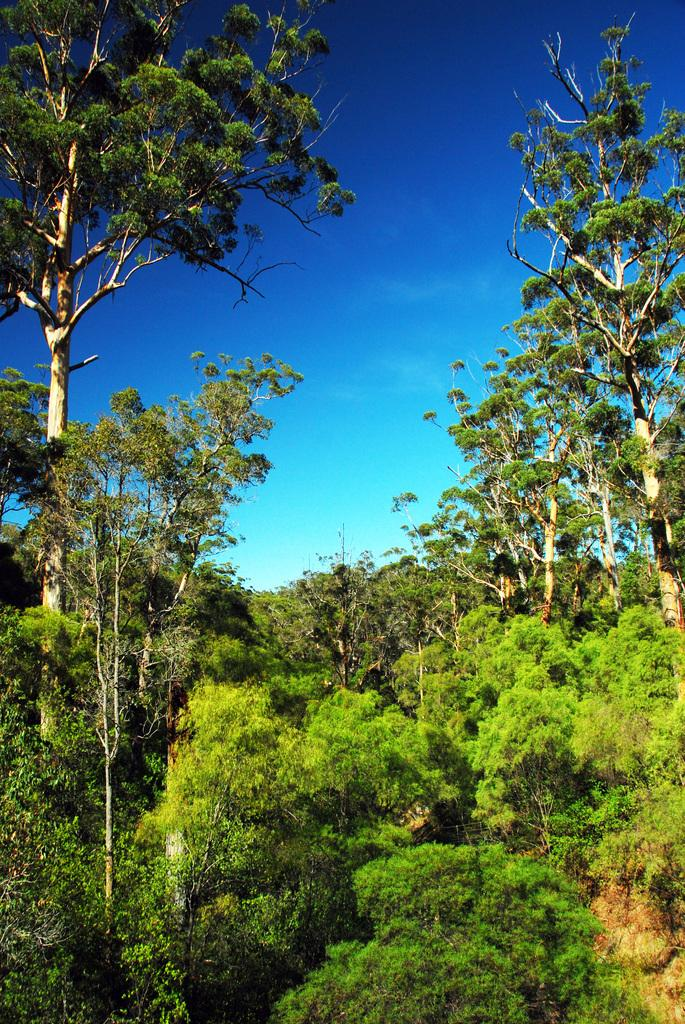What type of natural environment is depicted in the image? There is a forest in the image. What can be found within the forest? There are trees in the forest. What part of the sky is visible in the image? The sky is visible in the image. What color are the eyes of the animal in the image? There are no animals or eyes visible in the image; it depicts a forest with trees and the sky. 